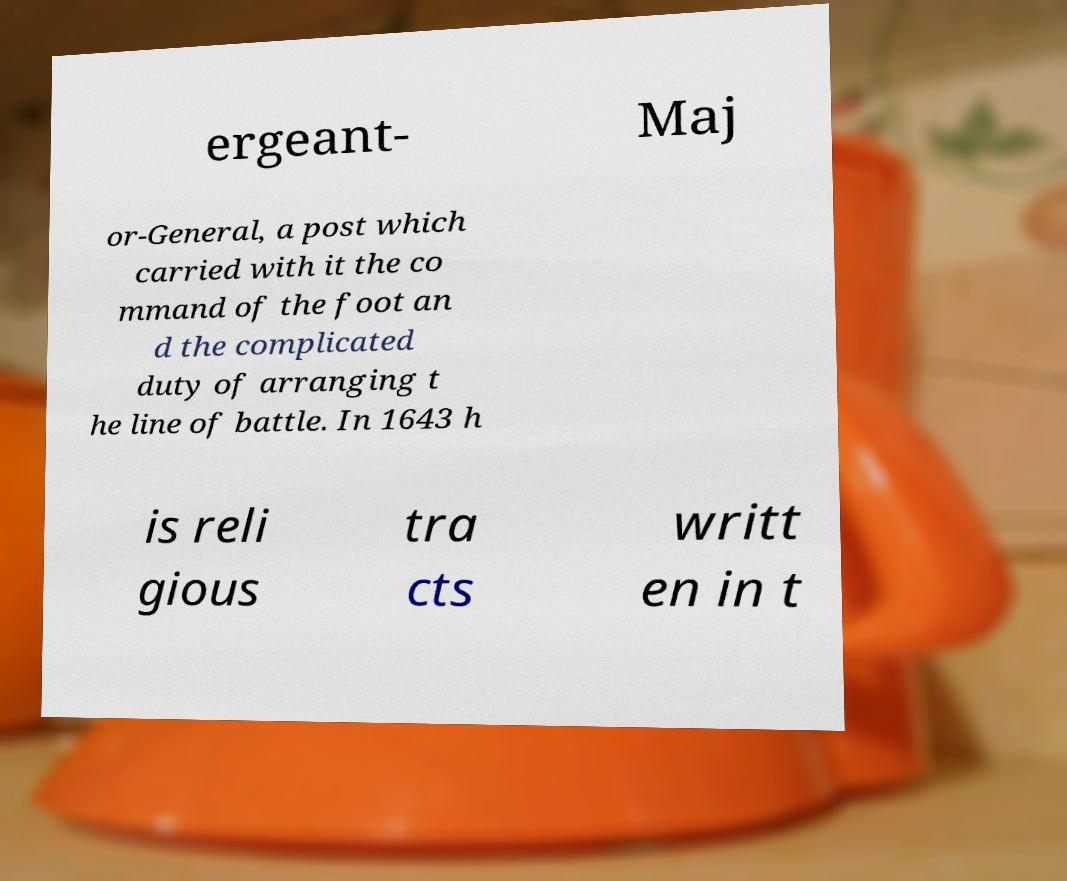There's text embedded in this image that I need extracted. Can you transcribe it verbatim? ergeant- Maj or-General, a post which carried with it the co mmand of the foot an d the complicated duty of arranging t he line of battle. In 1643 h is reli gious tra cts writt en in t 